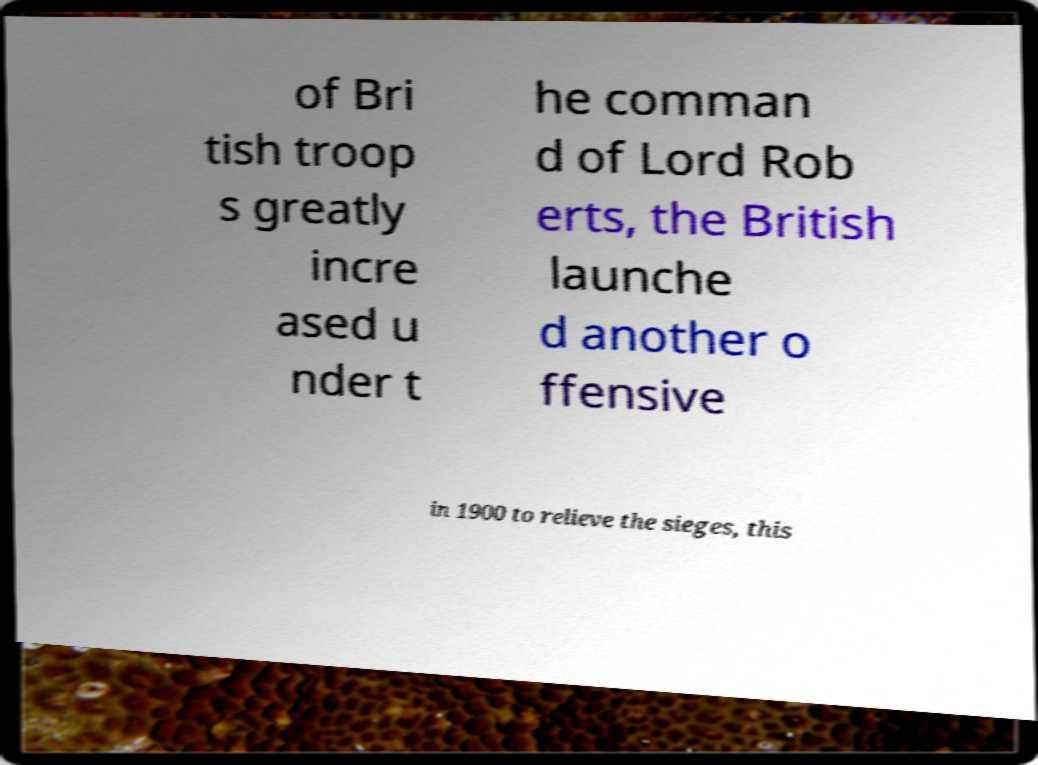For documentation purposes, I need the text within this image transcribed. Could you provide that? of Bri tish troop s greatly incre ased u nder t he comman d of Lord Rob erts, the British launche d another o ffensive in 1900 to relieve the sieges, this 